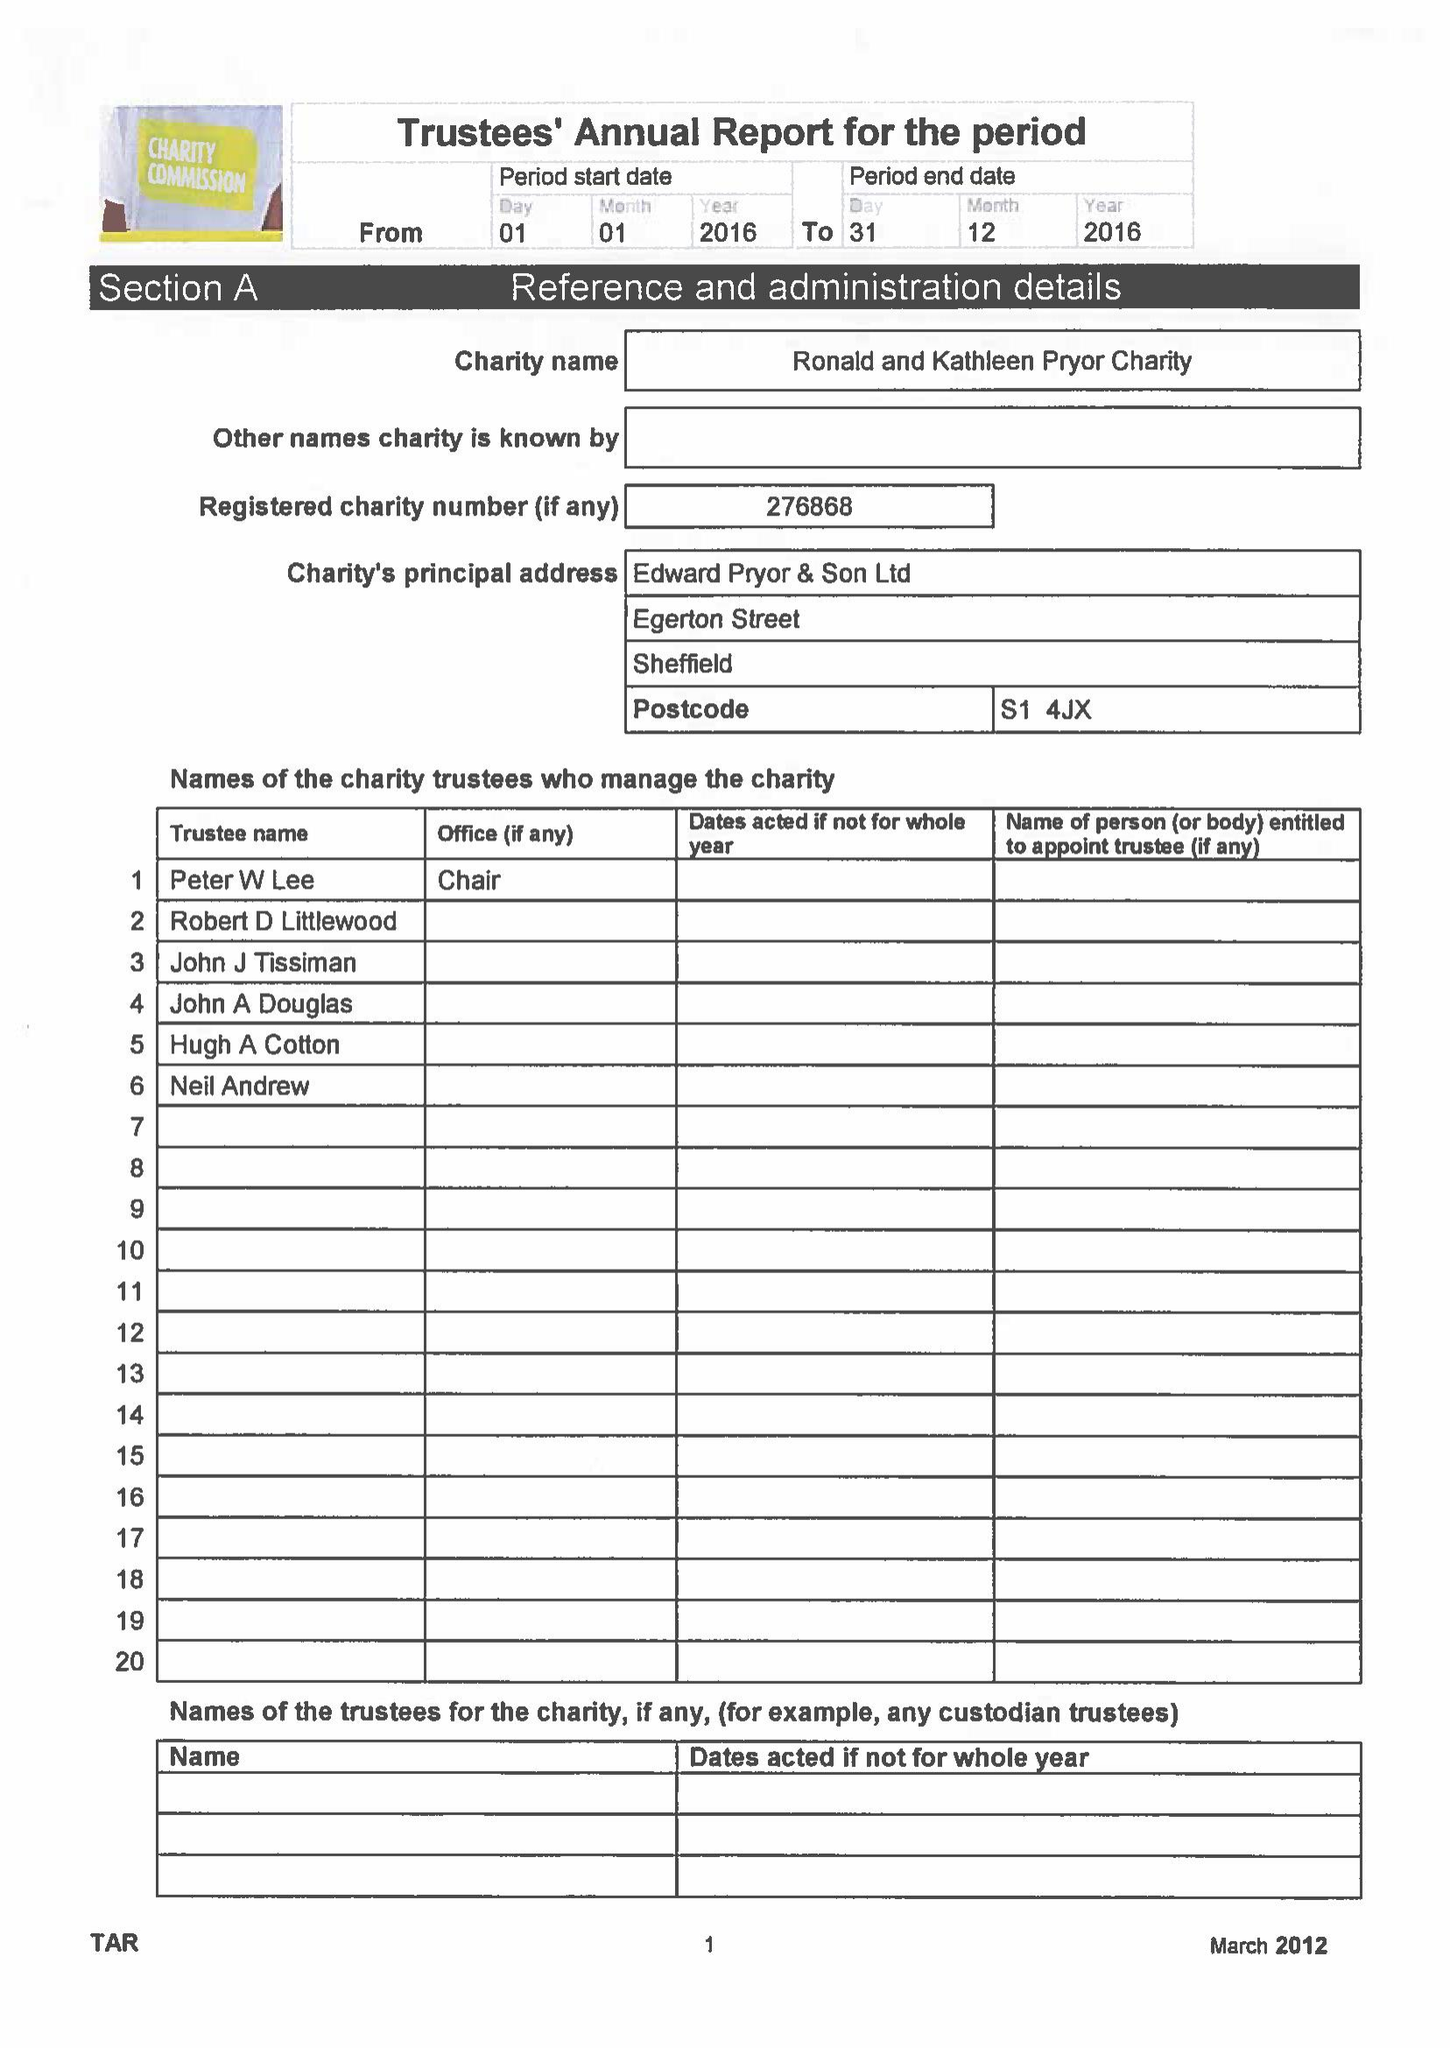What is the value for the address__street_line?
Answer the question using a single word or phrase. EGERTON STREET 